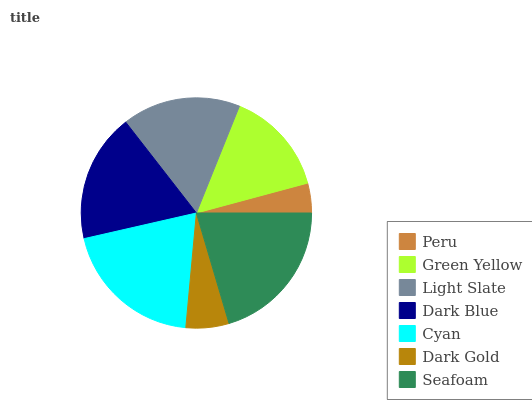Is Peru the minimum?
Answer yes or no. Yes. Is Seafoam the maximum?
Answer yes or no. Yes. Is Green Yellow the minimum?
Answer yes or no. No. Is Green Yellow the maximum?
Answer yes or no. No. Is Green Yellow greater than Peru?
Answer yes or no. Yes. Is Peru less than Green Yellow?
Answer yes or no. Yes. Is Peru greater than Green Yellow?
Answer yes or no. No. Is Green Yellow less than Peru?
Answer yes or no. No. Is Light Slate the high median?
Answer yes or no. Yes. Is Light Slate the low median?
Answer yes or no. Yes. Is Green Yellow the high median?
Answer yes or no. No. Is Dark Gold the low median?
Answer yes or no. No. 